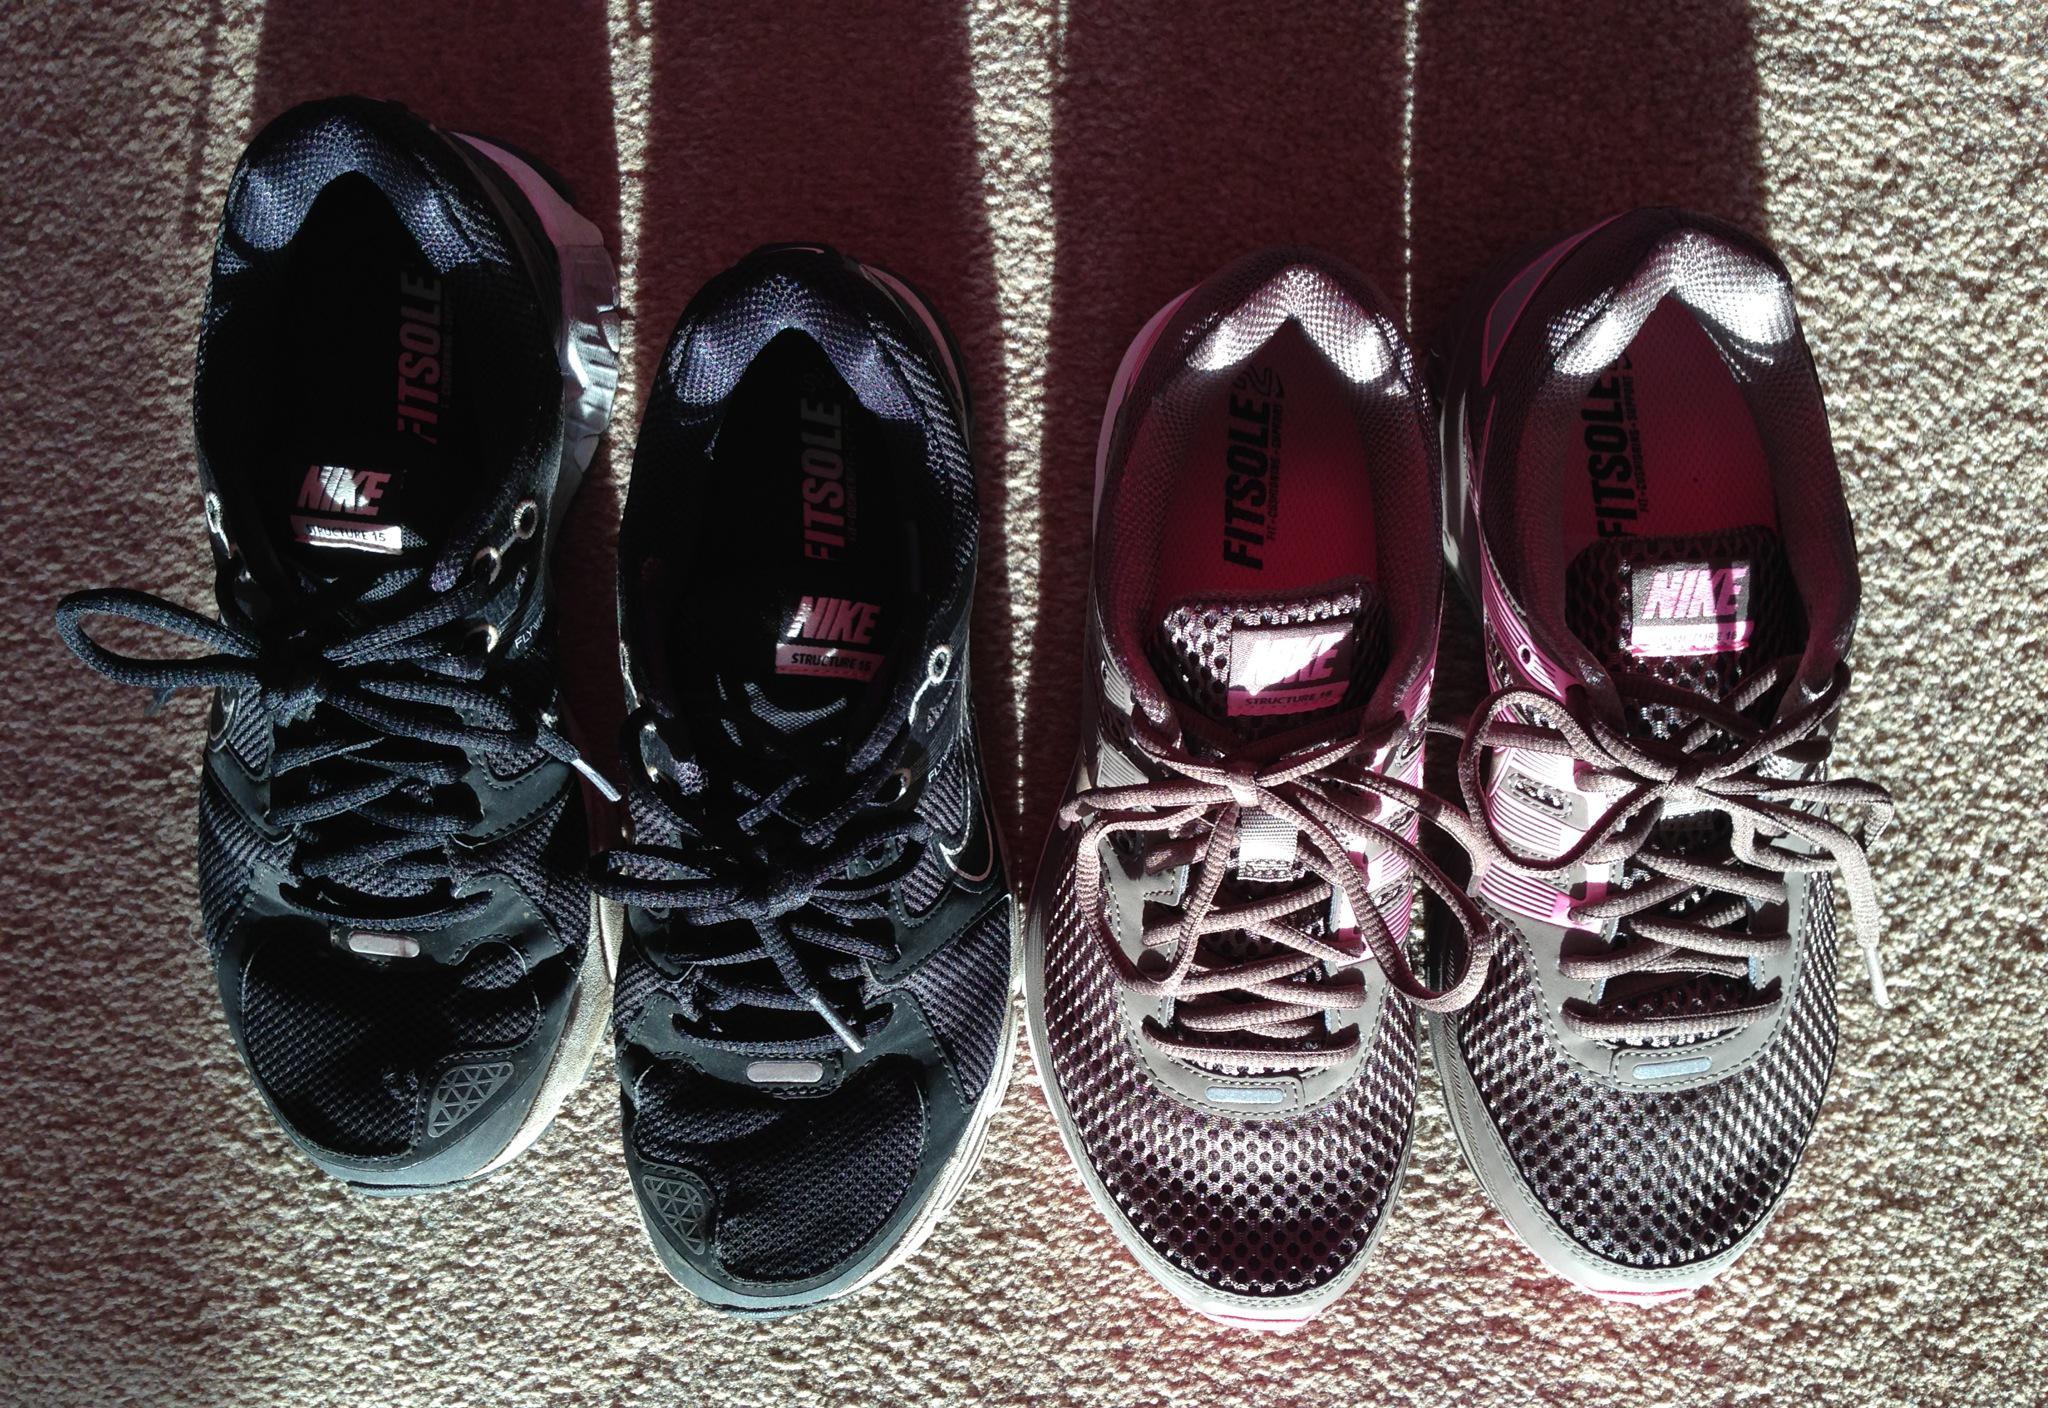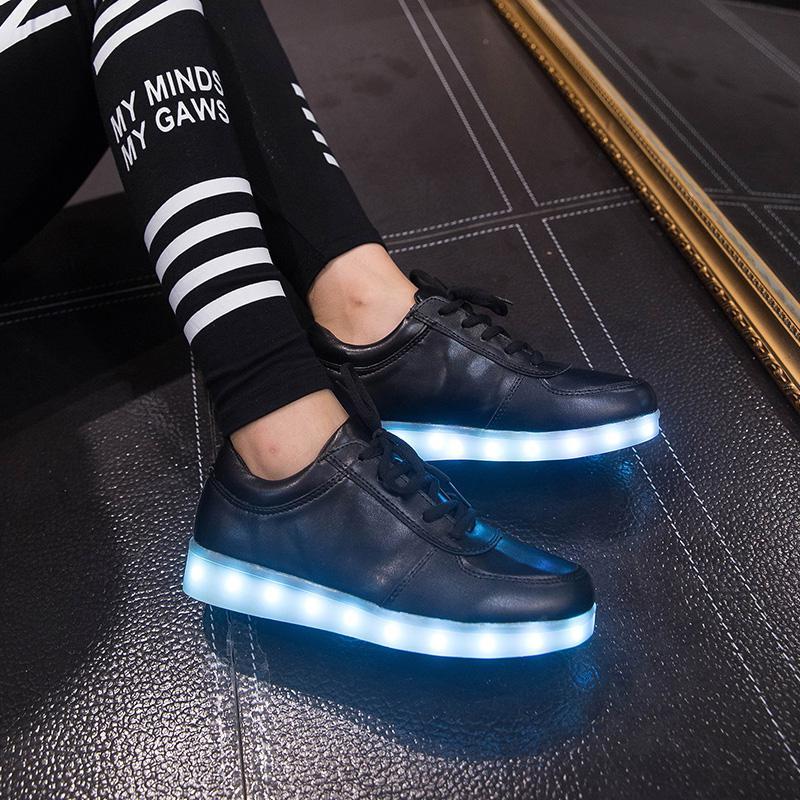The first image is the image on the left, the second image is the image on the right. Evaluate the accuracy of this statement regarding the images: "In one of the images, a pair of shoes with a white sole are modelled by a human.". Is it true? Answer yes or no. Yes. The first image is the image on the left, the second image is the image on the right. Given the left and right images, does the statement "Someone is wearing the shoes in one of the images." hold true? Answer yes or no. Yes. 